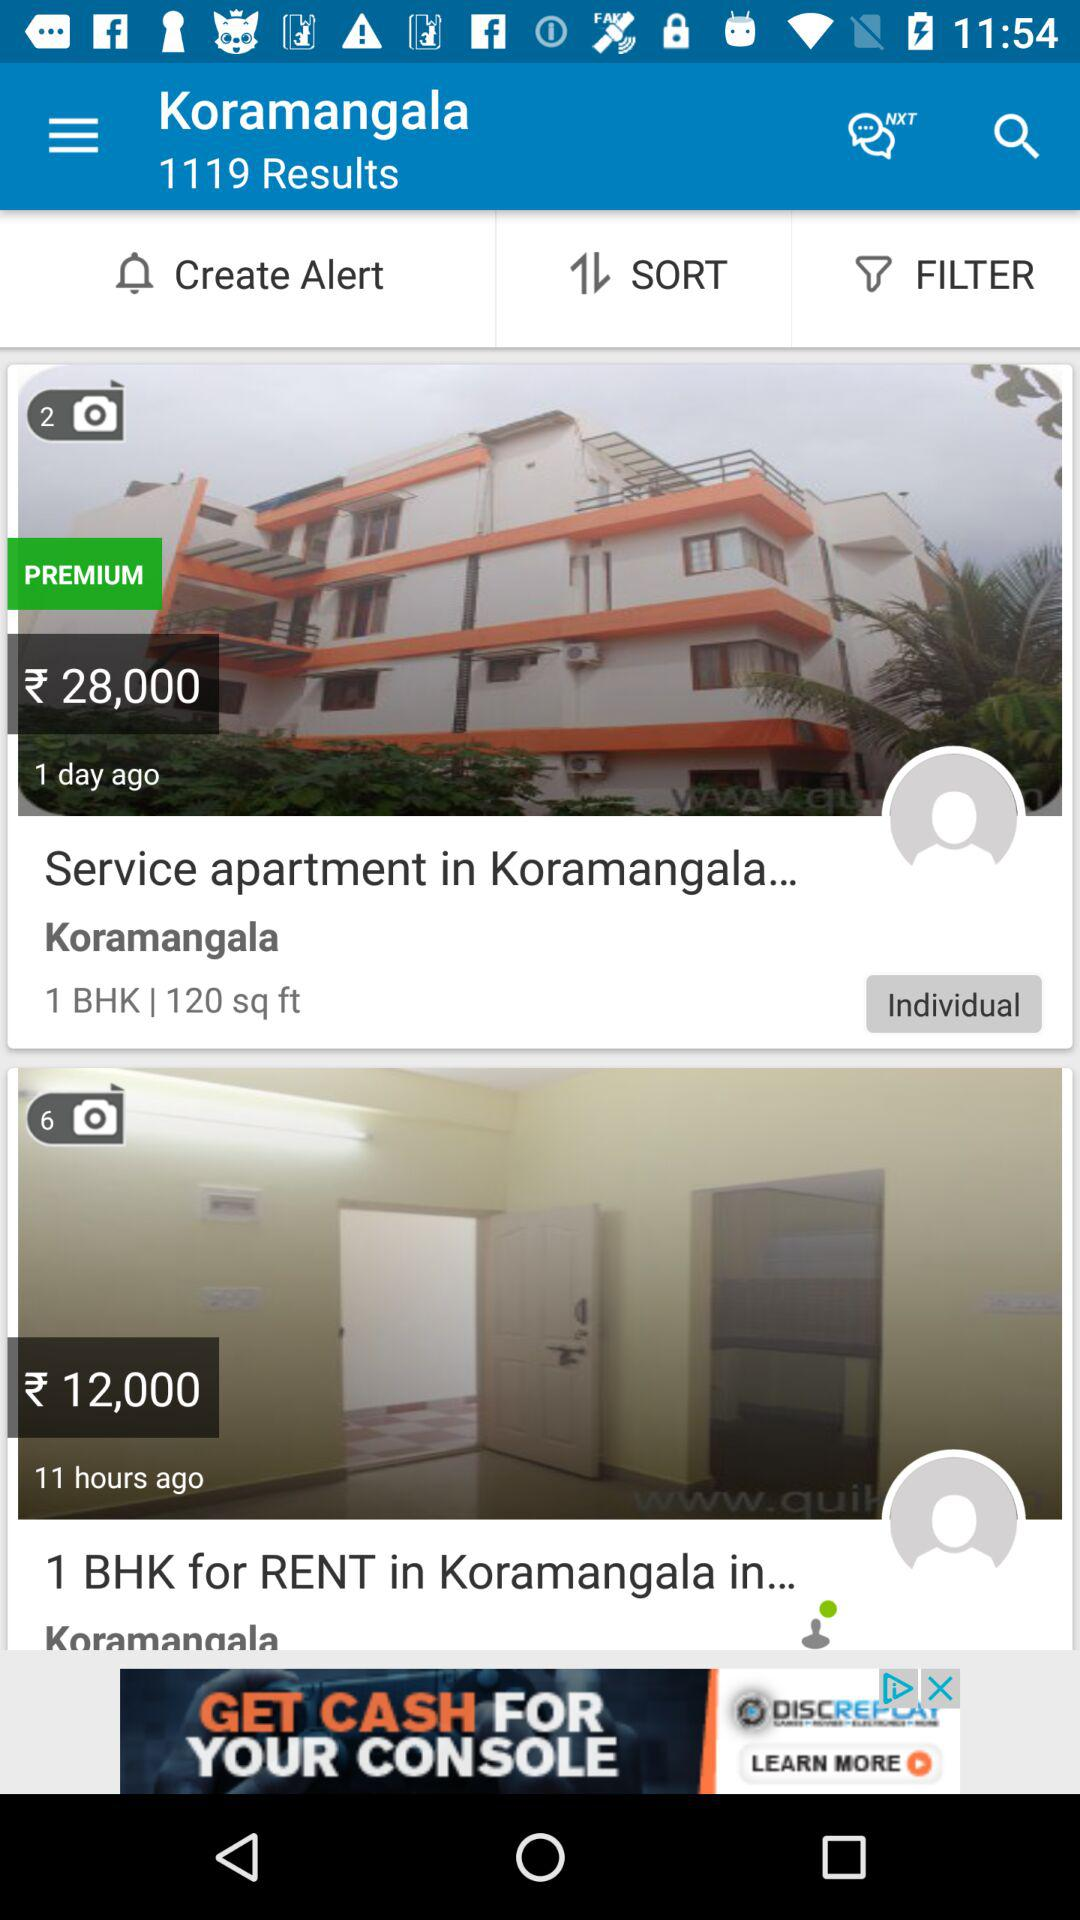What is the rent for the 1 BHK "Service apartment in Koramangala"? The rent is ₹28,000. 